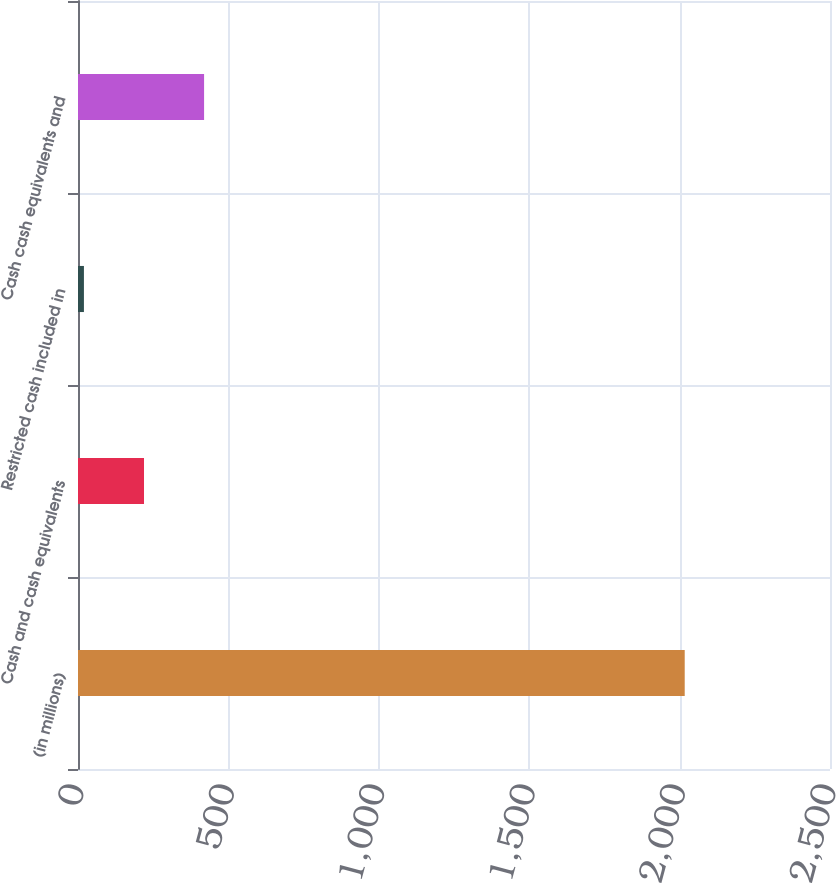Convert chart. <chart><loc_0><loc_0><loc_500><loc_500><bar_chart><fcel>(in millions)<fcel>Cash and cash equivalents<fcel>Restricted cash included in<fcel>Cash cash equivalents and<nl><fcel>2017<fcel>219.43<fcel>19.7<fcel>419.16<nl></chart> 